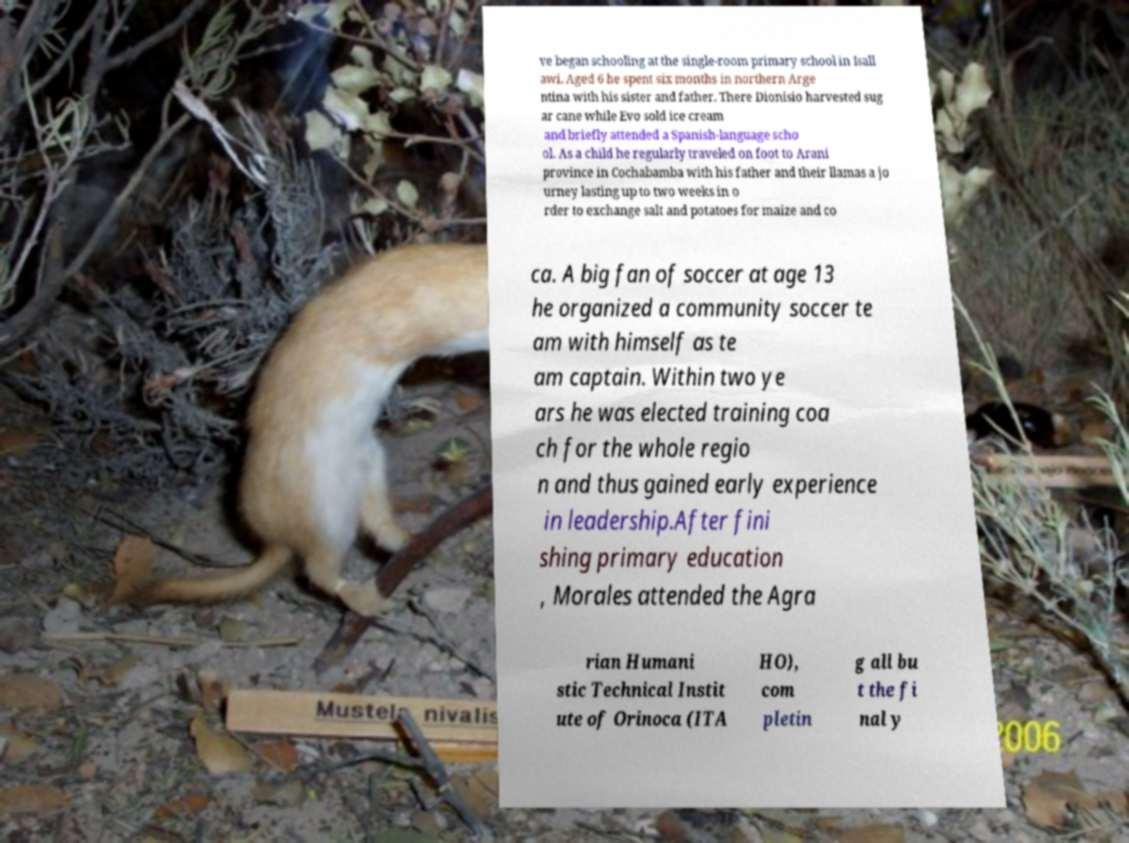I need the written content from this picture converted into text. Can you do that? ve began schooling at the single-room primary school in Isall awi. Aged 6 he spent six months in northern Arge ntina with his sister and father. There Dionisio harvested sug ar cane while Evo sold ice cream and briefly attended a Spanish-language scho ol. As a child he regularly traveled on foot to Arani province in Cochabamba with his father and their llamas a jo urney lasting up to two weeks in o rder to exchange salt and potatoes for maize and co ca. A big fan of soccer at age 13 he organized a community soccer te am with himself as te am captain. Within two ye ars he was elected training coa ch for the whole regio n and thus gained early experience in leadership.After fini shing primary education , Morales attended the Agra rian Humani stic Technical Instit ute of Orinoca (ITA HO), com pletin g all bu t the fi nal y 